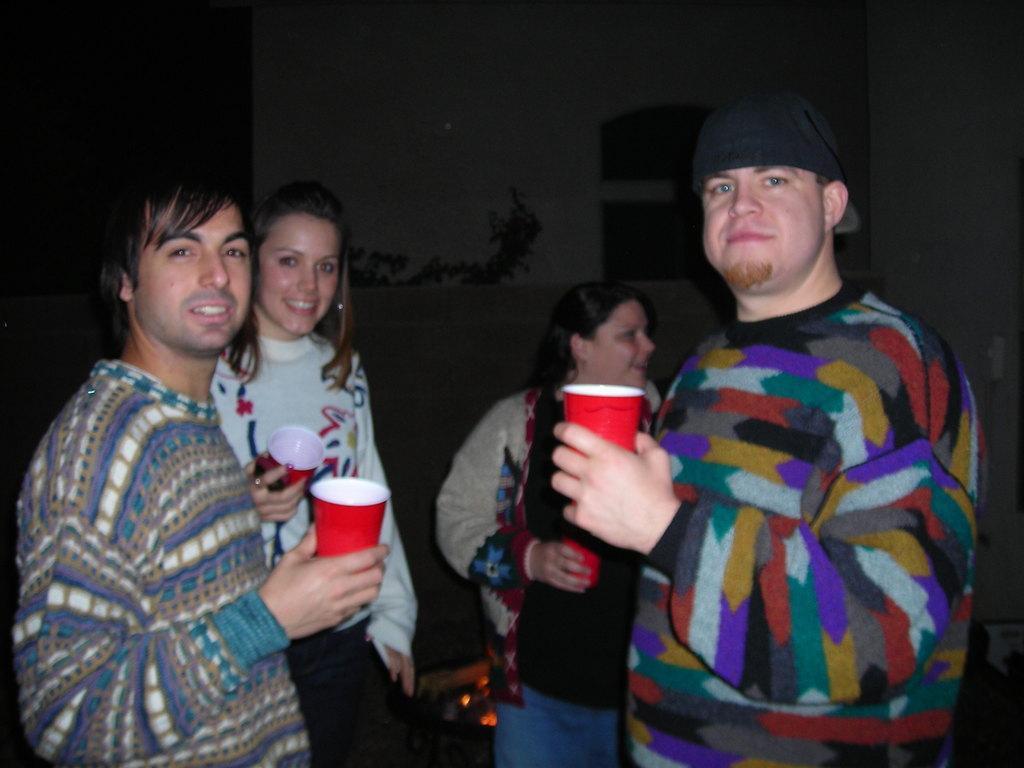Please provide a concise description of this image. In this image we can see people standing on the floor and holding disposable tumblers in their hands. 